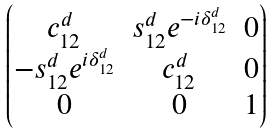Convert formula to latex. <formula><loc_0><loc_0><loc_500><loc_500>\begin{pmatrix} c _ { 1 2 } ^ { d } & s _ { 1 2 } ^ { d } e ^ { - i \delta ^ { d } _ { 1 2 } } & 0 \\ - s _ { 1 2 } ^ { d } e ^ { i \delta ^ { d } _ { 1 2 } } & c _ { 1 2 } ^ { d } & 0 \\ 0 & 0 & 1 \\ \end{pmatrix}</formula> 